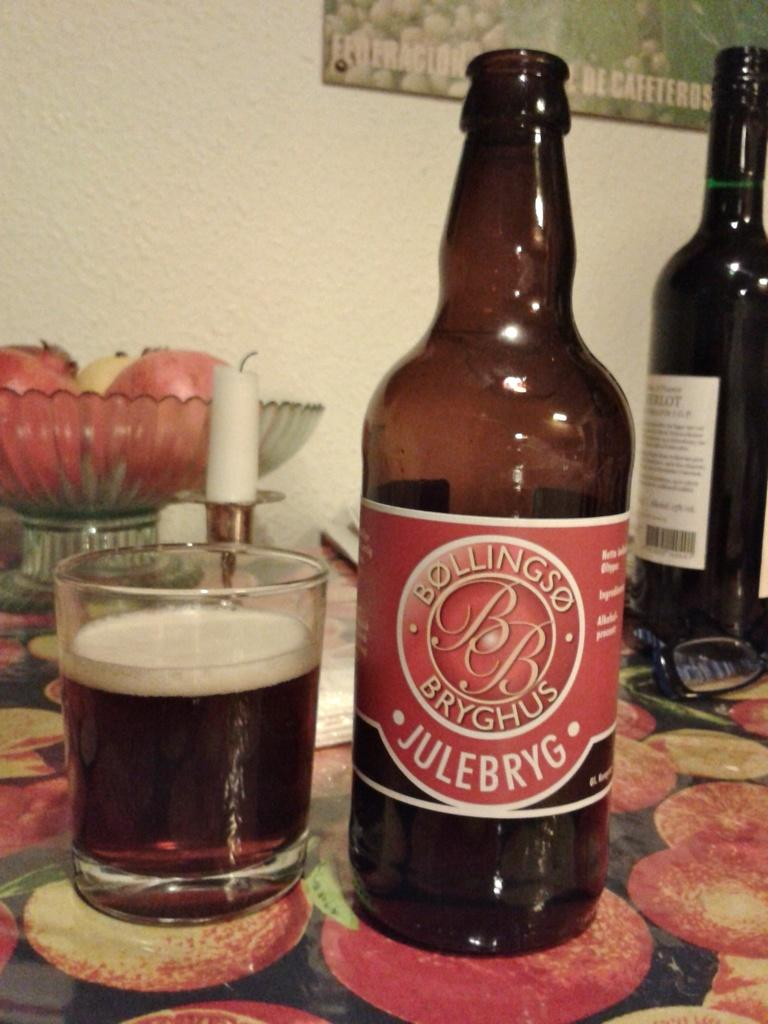<image>
Relay a brief, clear account of the picture shown. A glass bottle of a drink called Julebryg next to a drinking glass 